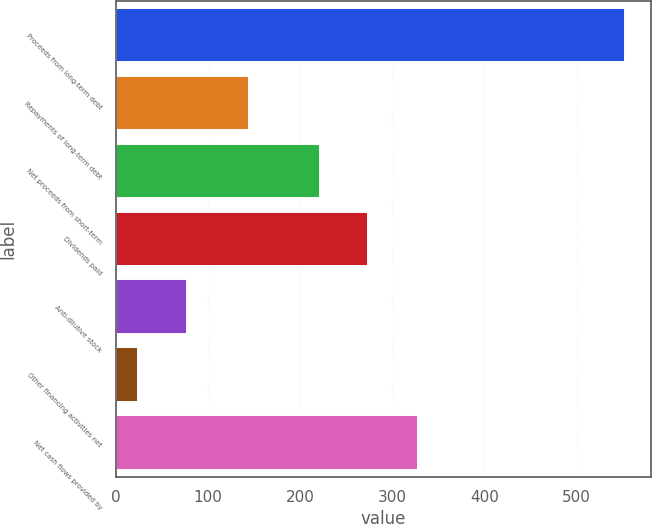<chart> <loc_0><loc_0><loc_500><loc_500><bar_chart><fcel>Proceeds from long-term debt<fcel>Repayments of long-term debt<fcel>Net proceeds from short-term<fcel>Dividends paid<fcel>Anti-dilutive stock<fcel>Other financing activities net<fcel>Net cash flows provided by<nl><fcel>553<fcel>144<fcel>221<fcel>273.9<fcel>76.9<fcel>24<fcel>328<nl></chart> 